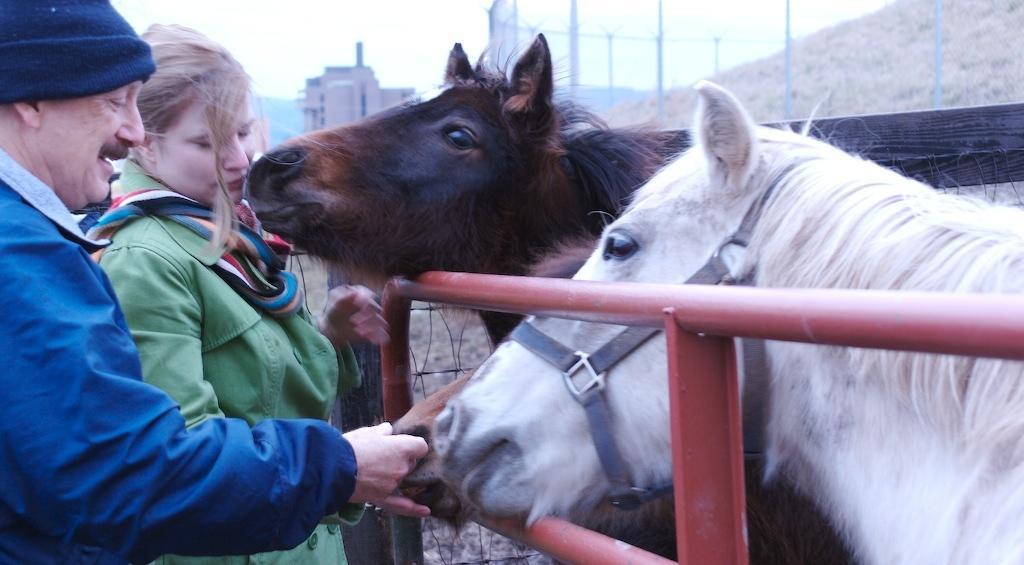Could you give a brief overview of what you see in this image? As we can see in the image there is a sky, building, horses and on the left side there are two people. 